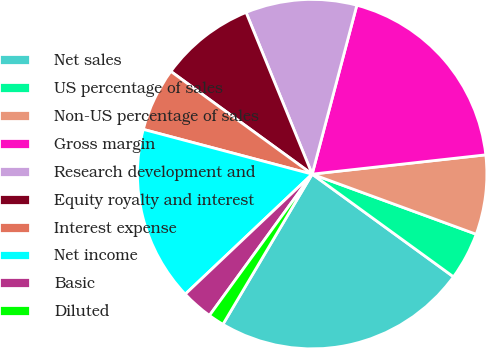<chart> <loc_0><loc_0><loc_500><loc_500><pie_chart><fcel>Net sales<fcel>US percentage of sales<fcel>Non-US percentage of sales<fcel>Gross margin<fcel>Research development and<fcel>Equity royalty and interest<fcel>Interest expense<fcel>Net income<fcel>Basic<fcel>Diluted<nl><fcel>23.53%<fcel>4.41%<fcel>7.35%<fcel>19.12%<fcel>10.29%<fcel>8.82%<fcel>5.88%<fcel>16.18%<fcel>2.94%<fcel>1.47%<nl></chart> 